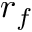Convert formula to latex. <formula><loc_0><loc_0><loc_500><loc_500>r _ { f }</formula> 